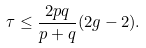Convert formula to latex. <formula><loc_0><loc_0><loc_500><loc_500>\tau \leq \frac { 2 p q } { p + q } ( 2 g - 2 ) .</formula> 